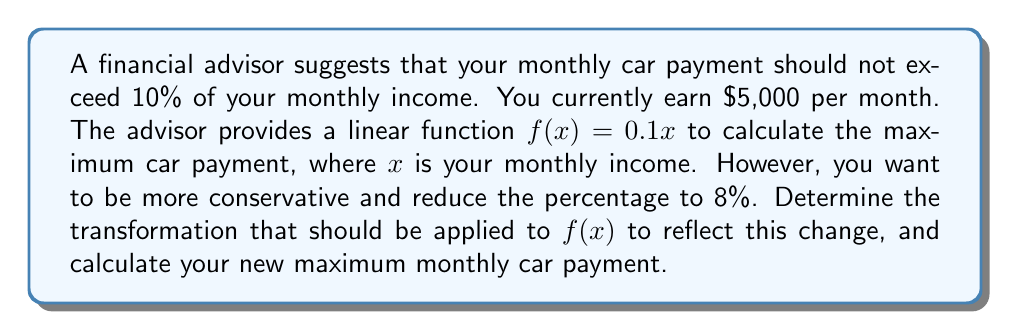Teach me how to tackle this problem. 1. The original function is $f(x) = 0.1x$, which represents 10% of the monthly income.

2. To reduce the percentage from 10% to 8%, we need to multiply the function by $\frac{8}{10}$ or $0.8$.

3. The transformation can be expressed as $g(x) = 0.8f(x)$.

4. Substituting the original function, we get:
   $g(x) = 0.8(0.1x) = 0.08x$

5. To find the maximum monthly car payment, we substitute your monthly income ($5,000) into the new function:
   $g(5000) = 0.08(5000) = 400$

Therefore, the transformed function is $g(x) = 0.08x$, and your new maximum monthly car payment is $400.
Answer: $g(x) = 0.08x$; $400 